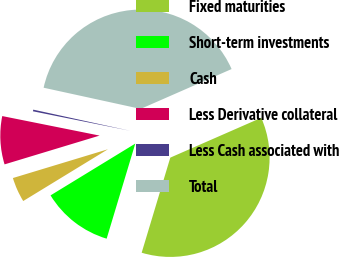Convert chart to OTSL. <chart><loc_0><loc_0><loc_500><loc_500><pie_chart><fcel>Fixed maturities<fcel>Short-term investments<fcel>Cash<fcel>Less Derivative collateral<fcel>Less Cash associated with<fcel>Total<nl><fcel>36.22%<fcel>11.61%<fcel>4.05%<fcel>7.83%<fcel>0.27%<fcel>40.0%<nl></chart> 